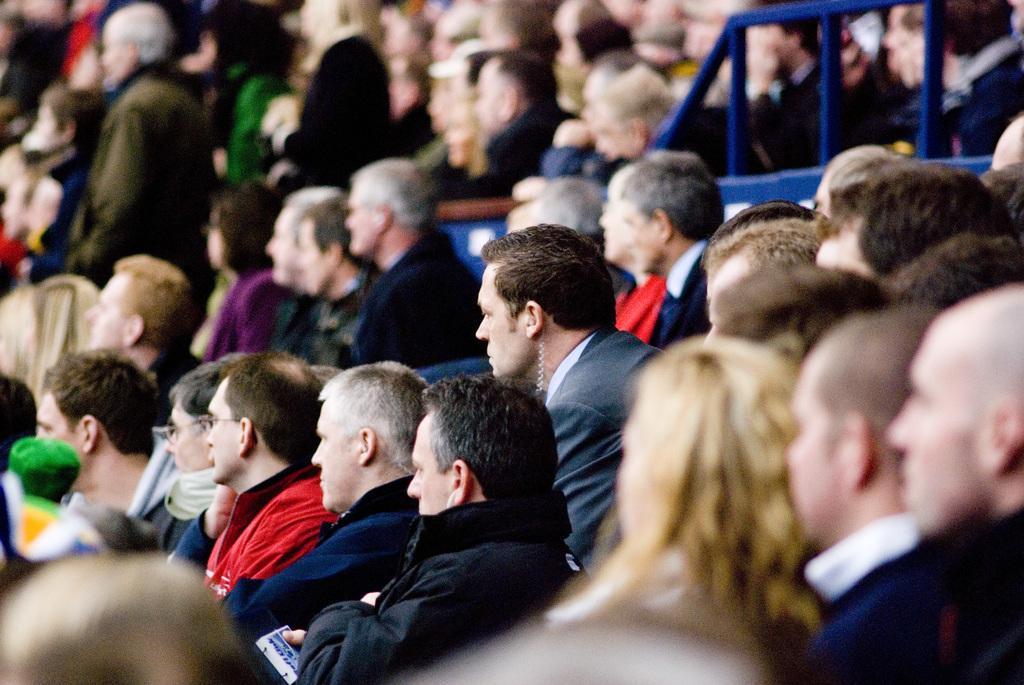Can you describe this image briefly? In this image I can see a group of people and they are wearing different color dresses. Background is blurred. 